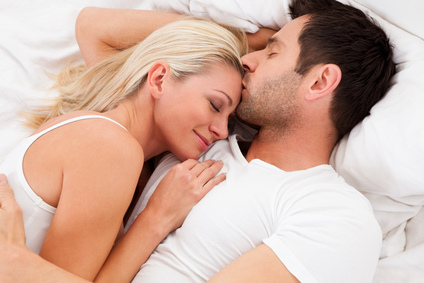<image>Is this an ad for Viagra? It is unclear whether this is an ad for Viagra. Is this an ad for Viagra? I don't know if this is an ad for Viagra. It is unclear. 